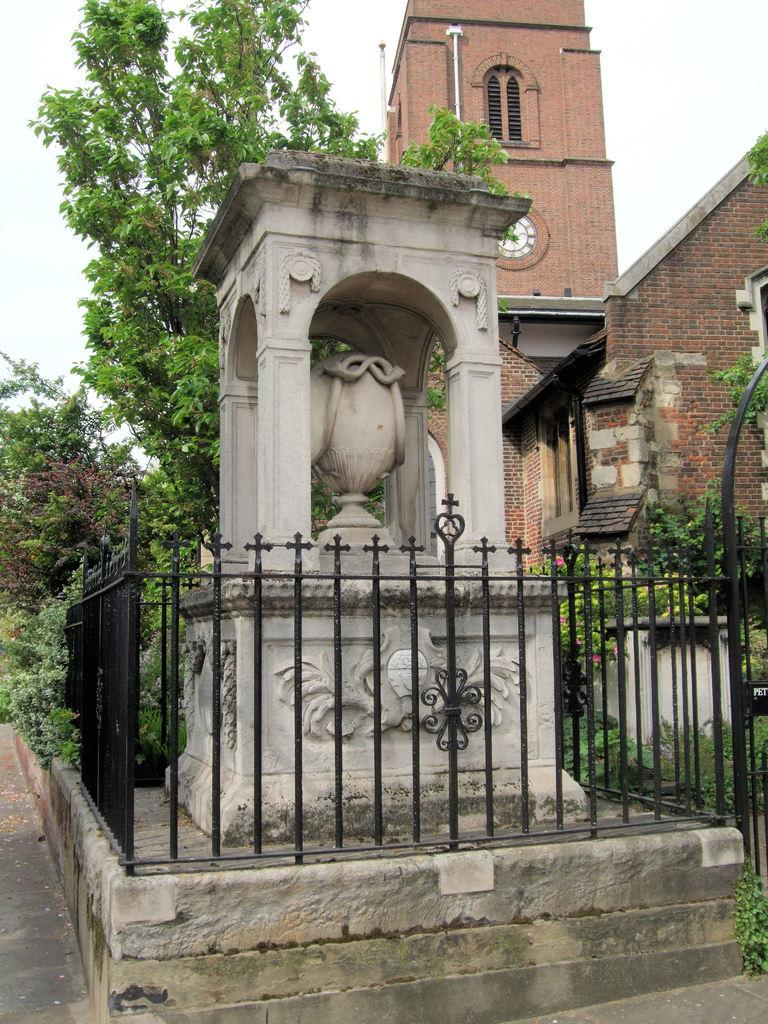What type of structure is present in the image? There is a building in the image. What feature can be seen on the building tower? There is a clock on the building tower of the building. What type of barrier is visible in the image? There is a fence in the image. What type of vegetation is present in the image? There are trees in the image. What other objects can be seen on the ground? There are other objects on the ground. What can be seen in the background of the image? The sky is visible in the background of the image. How does the bag blow away in the image? There is no bag present in the image, so it cannot blow away. 